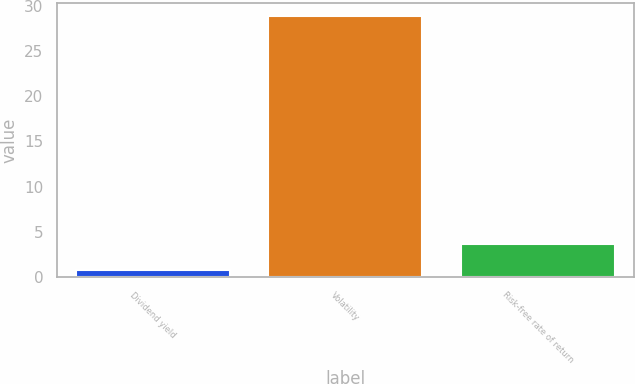<chart> <loc_0><loc_0><loc_500><loc_500><bar_chart><fcel>Dividend yield<fcel>Volatility<fcel>Risk-free rate of return<nl><fcel>0.83<fcel>28.85<fcel>3.63<nl></chart> 